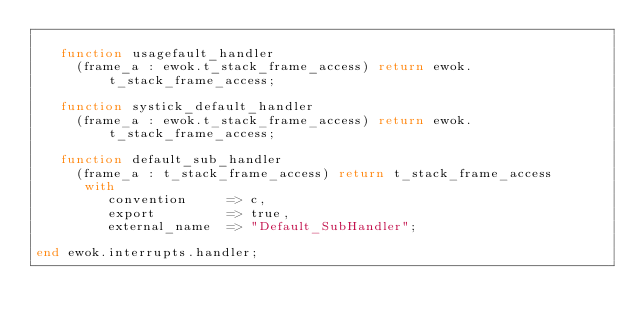Convert code to text. <code><loc_0><loc_0><loc_500><loc_500><_Ada_>
   function usagefault_handler
     (frame_a : ewok.t_stack_frame_access) return ewok.t_stack_frame_access;

   function systick_default_handler
     (frame_a : ewok.t_stack_frame_access) return ewok.t_stack_frame_access;

   function default_sub_handler
     (frame_a : t_stack_frame_access) return t_stack_frame_access
      with
         convention     => c,
         export         => true,
         external_name  => "Default_SubHandler";

end ewok.interrupts.handler;
</code> 